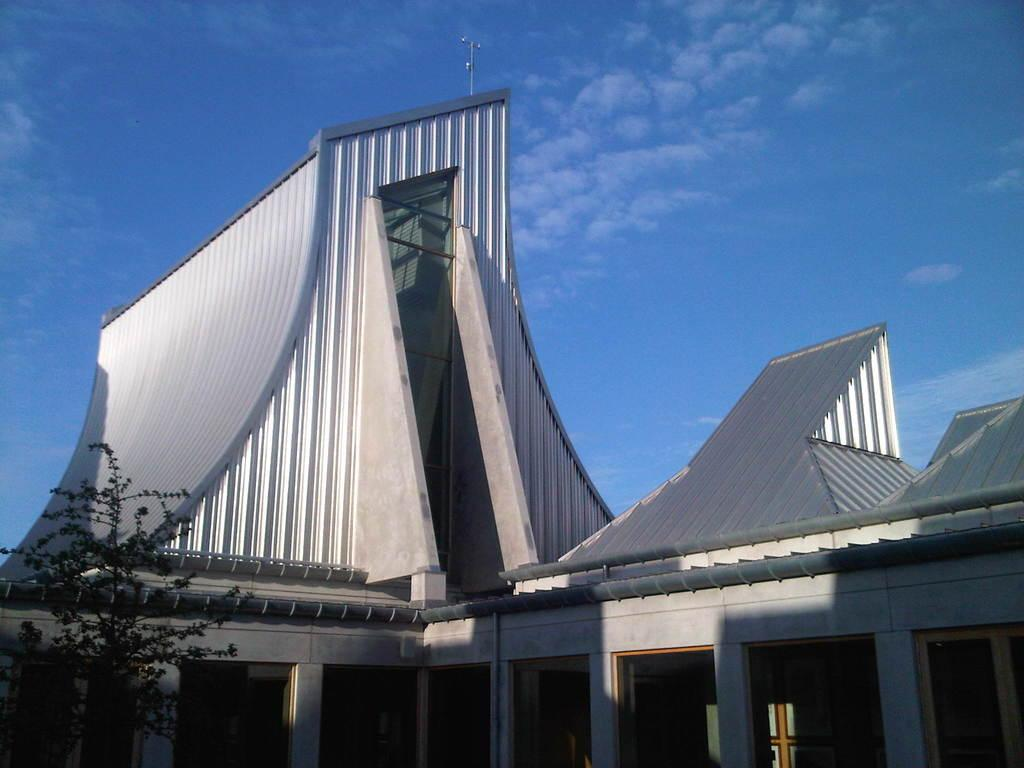What type of structures can be seen in the image? There are buildings in the image. What other natural elements are present in the image? There are trees in the image. Can you identify any man-made objects in the image? Yes, there is an antenna in the image. What is visible in the background of the image? The sky is visible in the background of the image. What is the condition of the sky in the image? There are clouds in the sky. How does the clam contribute to the functionality of the system in the image? There is no clam present in the image, and therefore it cannot contribute to any system. What type of stop is visible in the image? There is no stop visible in the image. 